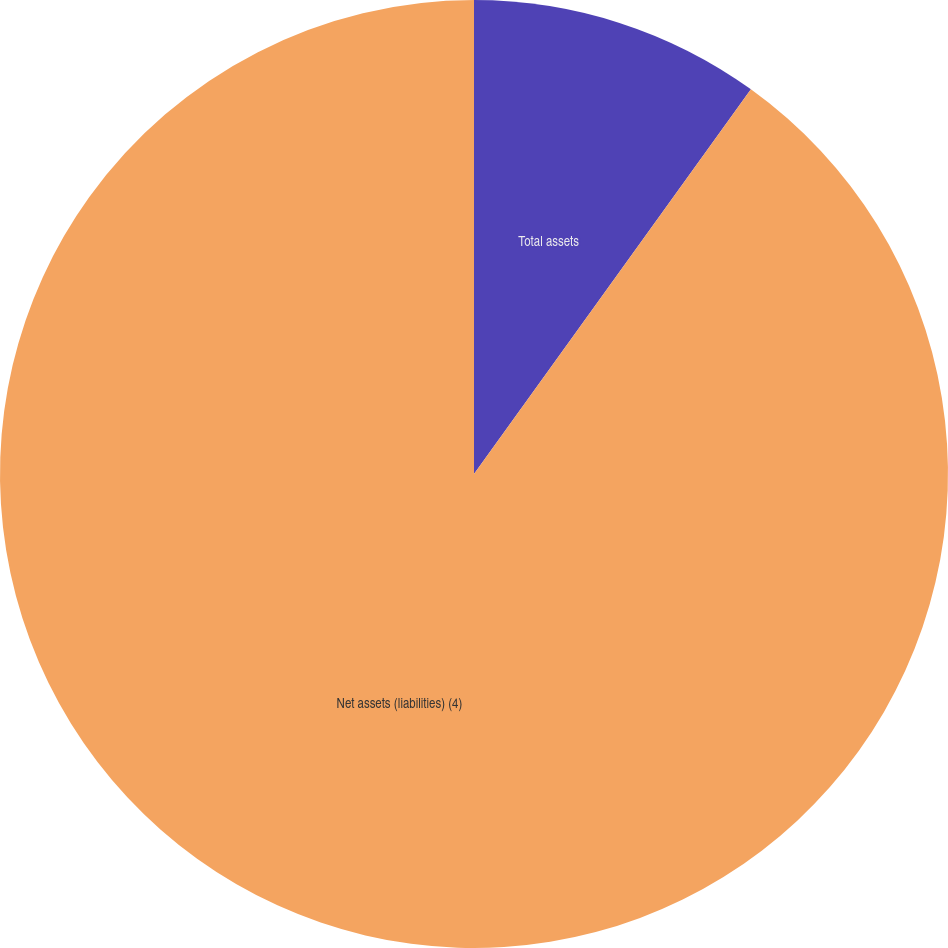<chart> <loc_0><loc_0><loc_500><loc_500><pie_chart><fcel>Total assets<fcel>Net assets (liabilities) (4)<nl><fcel>9.93%<fcel>90.07%<nl></chart> 